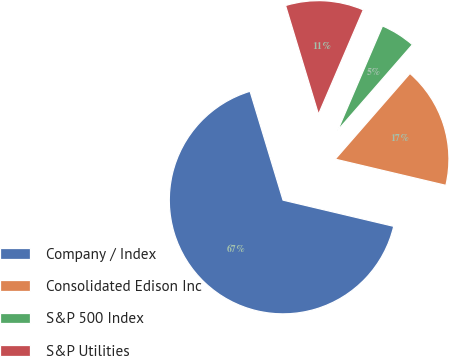Convert chart to OTSL. <chart><loc_0><loc_0><loc_500><loc_500><pie_chart><fcel>Company / Index<fcel>Consolidated Edison Inc<fcel>S&P 500 Index<fcel>S&P Utilities<nl><fcel>66.62%<fcel>17.29%<fcel>4.96%<fcel>11.13%<nl></chart> 